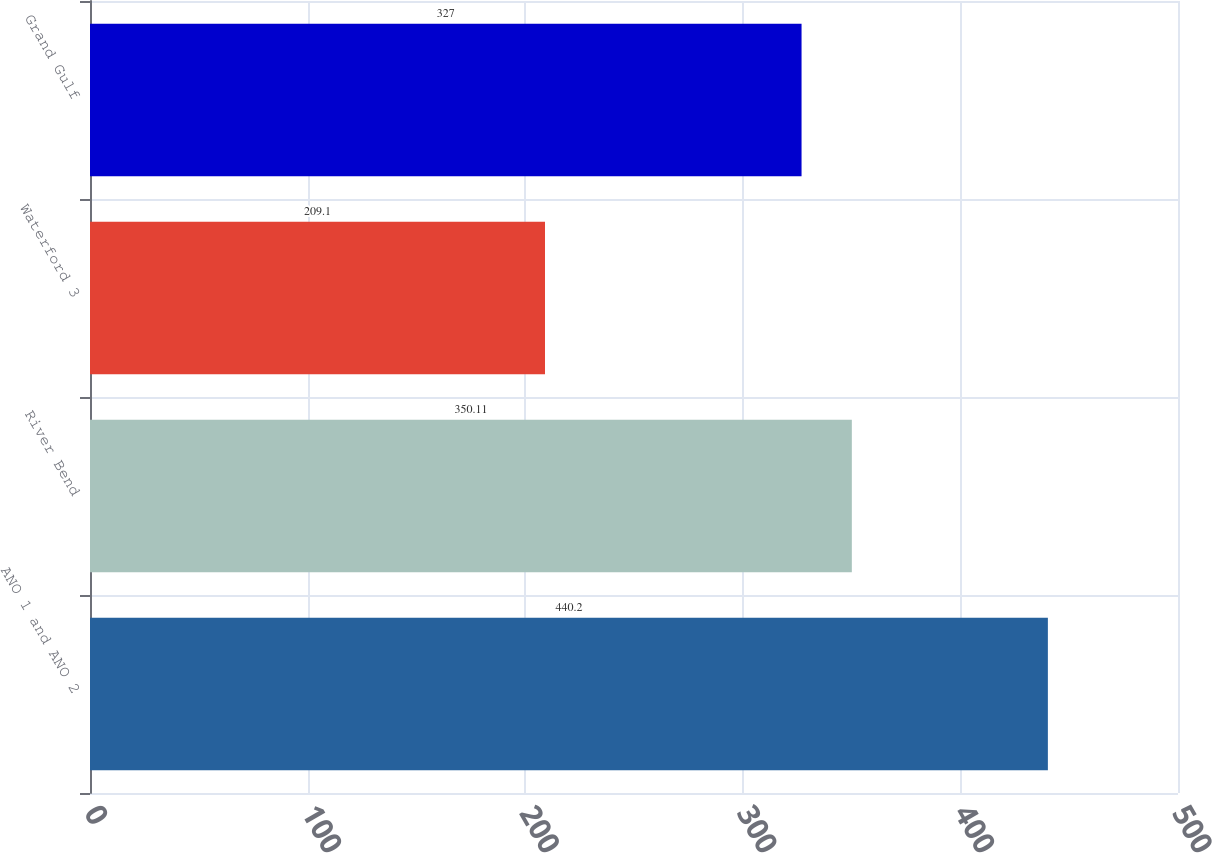Convert chart to OTSL. <chart><loc_0><loc_0><loc_500><loc_500><bar_chart><fcel>ANO 1 and ANO 2<fcel>River Bend<fcel>Waterford 3<fcel>Grand Gulf<nl><fcel>440.2<fcel>350.11<fcel>209.1<fcel>327<nl></chart> 